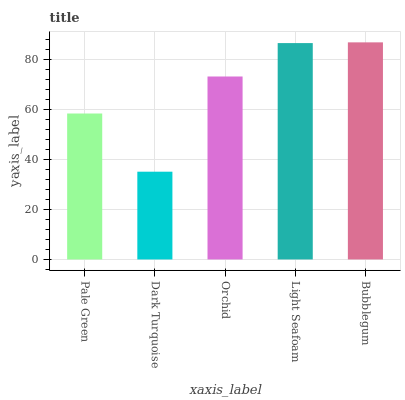Is Dark Turquoise the minimum?
Answer yes or no. Yes. Is Bubblegum the maximum?
Answer yes or no. Yes. Is Orchid the minimum?
Answer yes or no. No. Is Orchid the maximum?
Answer yes or no. No. Is Orchid greater than Dark Turquoise?
Answer yes or no. Yes. Is Dark Turquoise less than Orchid?
Answer yes or no. Yes. Is Dark Turquoise greater than Orchid?
Answer yes or no. No. Is Orchid less than Dark Turquoise?
Answer yes or no. No. Is Orchid the high median?
Answer yes or no. Yes. Is Orchid the low median?
Answer yes or no. Yes. Is Light Seafoam the high median?
Answer yes or no. No. Is Light Seafoam the low median?
Answer yes or no. No. 